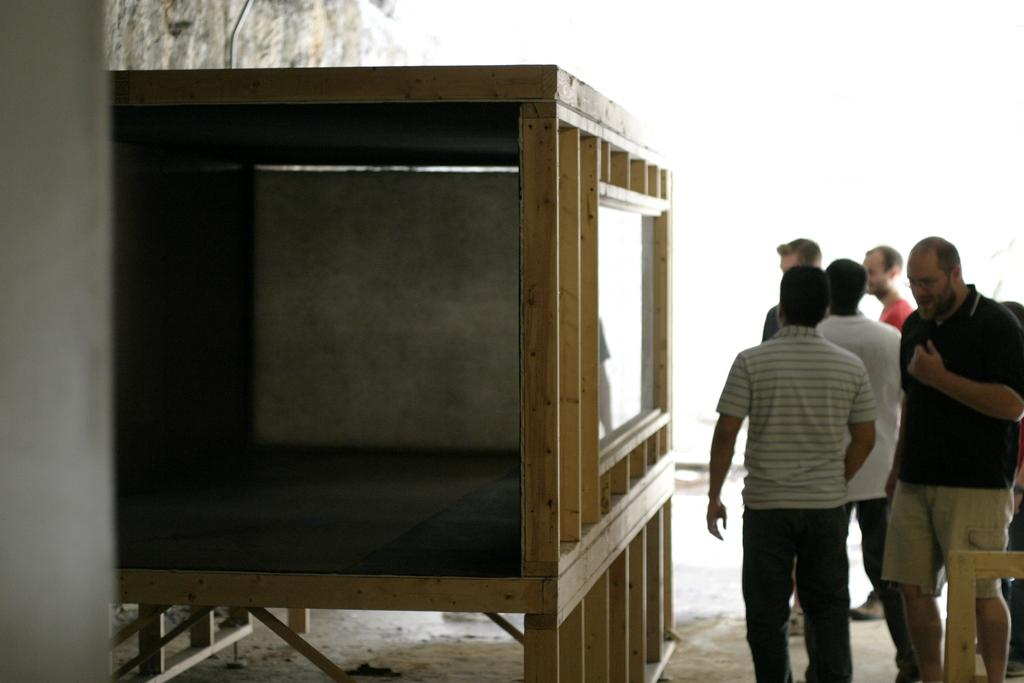What is located in the foreground on the left side of the image? There is a wooden cage-like structure in the foreground on the left side of the image. What can be seen on the right side of the image? There are people standing on the ground on the right side of the image. What type of structure is on the left side of the image? There is a stone wall on the left side of the image. How many sisters are standing on the left side of the image? There is no mention of sisters in the image, so we cannot determine the number of sisters present. What type of fork can be seen in the image? There is no fork present in the image. 